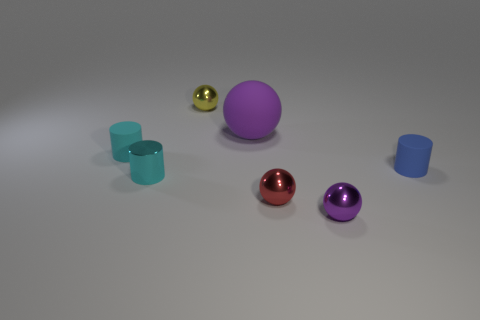Is the number of small yellow shiny objects behind the matte sphere greater than the number of yellow balls?
Offer a terse response. No. There is a small ball that is behind the tiny rubber cylinder on the right side of the red metallic sphere; what color is it?
Ensure brevity in your answer.  Yellow. How many things are shiny things in front of the tiny yellow shiny object or metallic things behind the big purple matte sphere?
Keep it short and to the point. 4. What color is the big rubber ball?
Your answer should be compact. Purple. What number of small cyan objects are made of the same material as the tiny yellow ball?
Your answer should be compact. 1. Is the number of large brown matte cylinders greater than the number of tiny red things?
Keep it short and to the point. No. There is a small sphere that is behind the small blue thing; how many small metallic things are in front of it?
Your answer should be compact. 3. How many things are rubber objects that are to the left of the big sphere or metallic objects?
Ensure brevity in your answer.  5. Are there any other cyan matte objects of the same shape as the big object?
Give a very brief answer. No. The small rubber object left of the purple ball that is behind the tiny purple metallic sphere is what shape?
Ensure brevity in your answer.  Cylinder. 